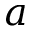Convert formula to latex. <formula><loc_0><loc_0><loc_500><loc_500>a</formula> 